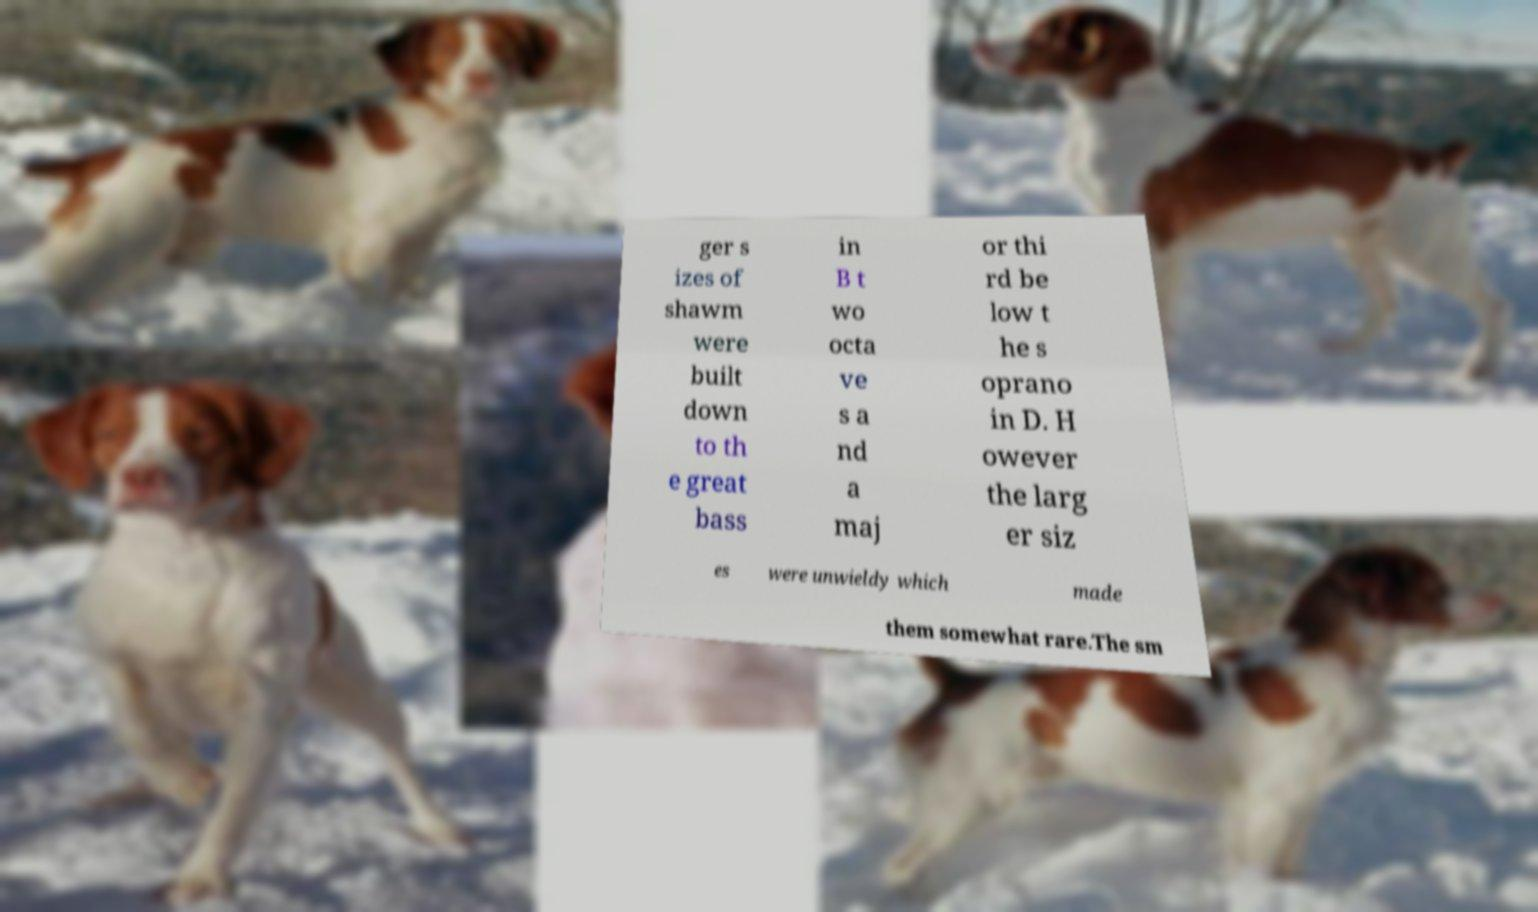What messages or text are displayed in this image? I need them in a readable, typed format. ger s izes of shawm were built down to th e great bass in B t wo octa ve s a nd a maj or thi rd be low t he s oprano in D. H owever the larg er siz es were unwieldy which made them somewhat rare.The sm 